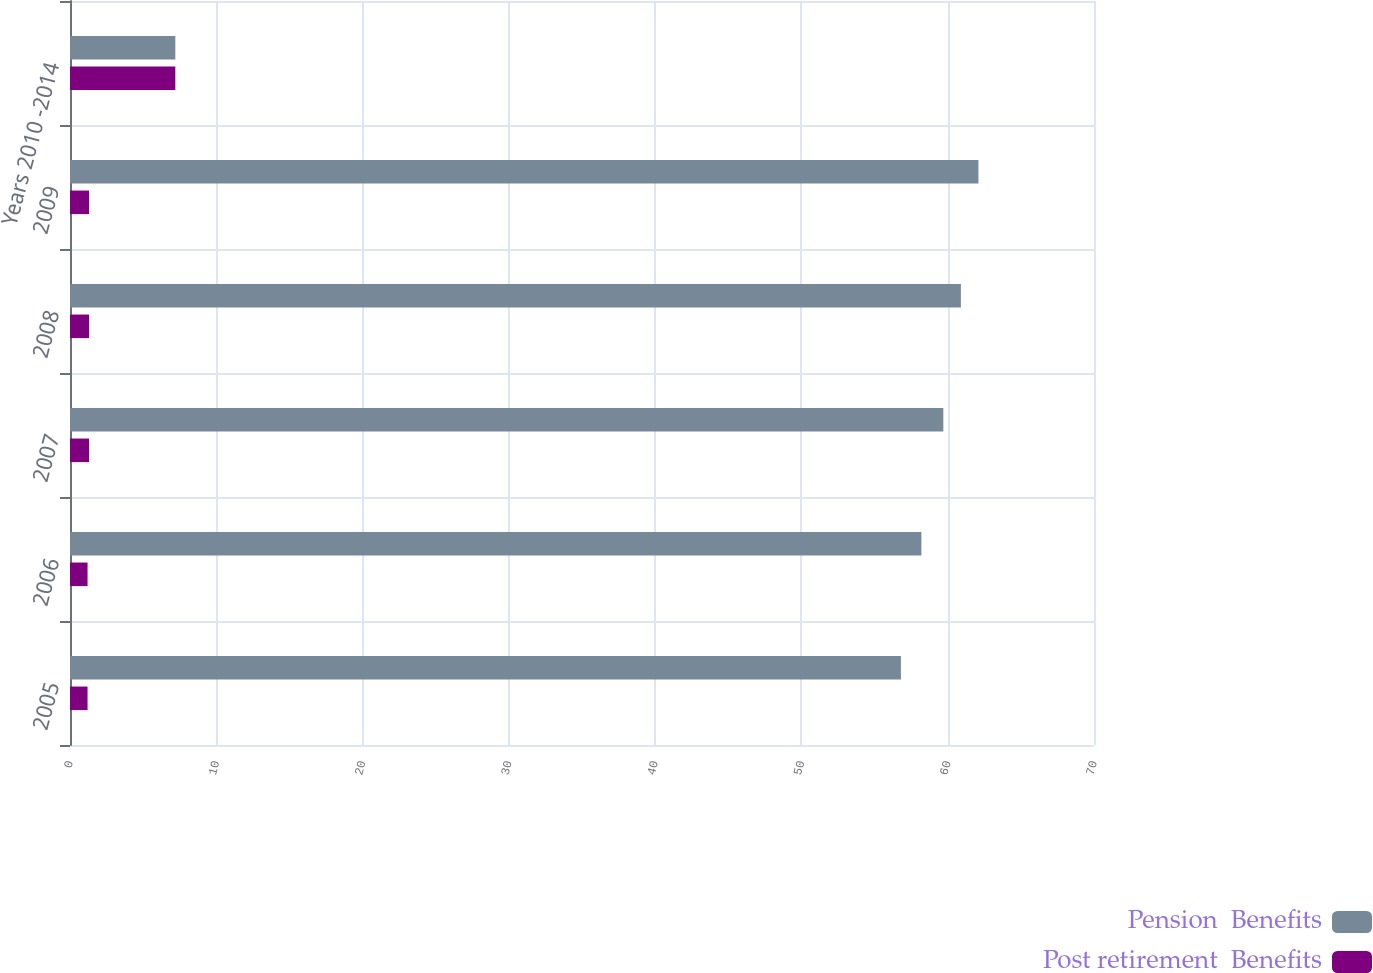Convert chart to OTSL. <chart><loc_0><loc_0><loc_500><loc_500><stacked_bar_chart><ecel><fcel>2005<fcel>2006<fcel>2007<fcel>2008<fcel>2009<fcel>Years 2010 -2014<nl><fcel>Pension  Benefits<fcel>56.8<fcel>58.2<fcel>59.7<fcel>60.9<fcel>62.1<fcel>7.2<nl><fcel>Post retirement  Benefits<fcel>1.2<fcel>1.2<fcel>1.3<fcel>1.3<fcel>1.3<fcel>7.2<nl></chart> 